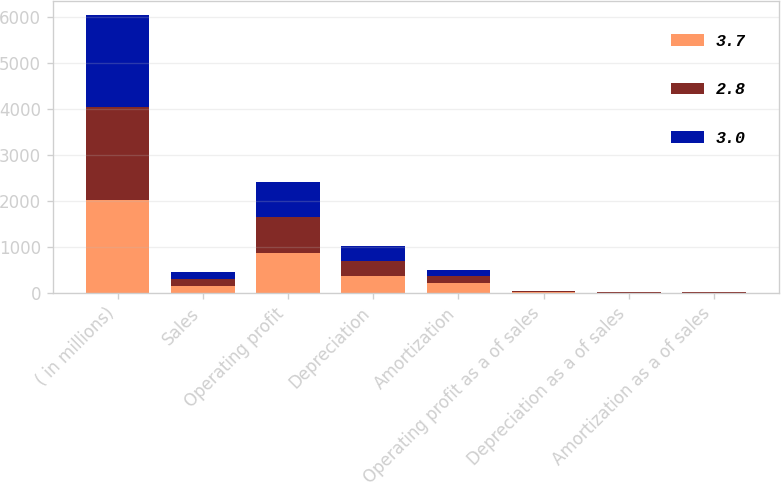Convert chart. <chart><loc_0><loc_0><loc_500><loc_500><stacked_bar_chart><ecel><fcel>( in millions)<fcel>Sales<fcel>Operating profit<fcel>Depreciation<fcel>Amortization<fcel>Operating profit as a of sales<fcel>Depreciation as a of sales<fcel>Amortization as a of sales<nl><fcel>3.7<fcel>2017<fcel>149.4<fcel>871.6<fcel>368.1<fcel>213.4<fcel>14.9<fcel>6.3<fcel>3.7<nl><fcel>2.8<fcel>2016<fcel>149.4<fcel>786.4<fcel>332.1<fcel>149.4<fcel>15.6<fcel>6.6<fcel>3<nl><fcel>3<fcel>2015<fcel>149.4<fcel>746.2<fcel>314.9<fcel>134.8<fcel>15.4<fcel>6.5<fcel>2.8<nl></chart> 